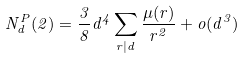Convert formula to latex. <formula><loc_0><loc_0><loc_500><loc_500>N _ { d } ^ { P } ( 2 ) = \frac { 3 } { 8 } d ^ { 4 } \sum _ { r | d } \frac { \mu ( r ) } { r ^ { 2 } } + o ( d ^ { 3 } )</formula> 